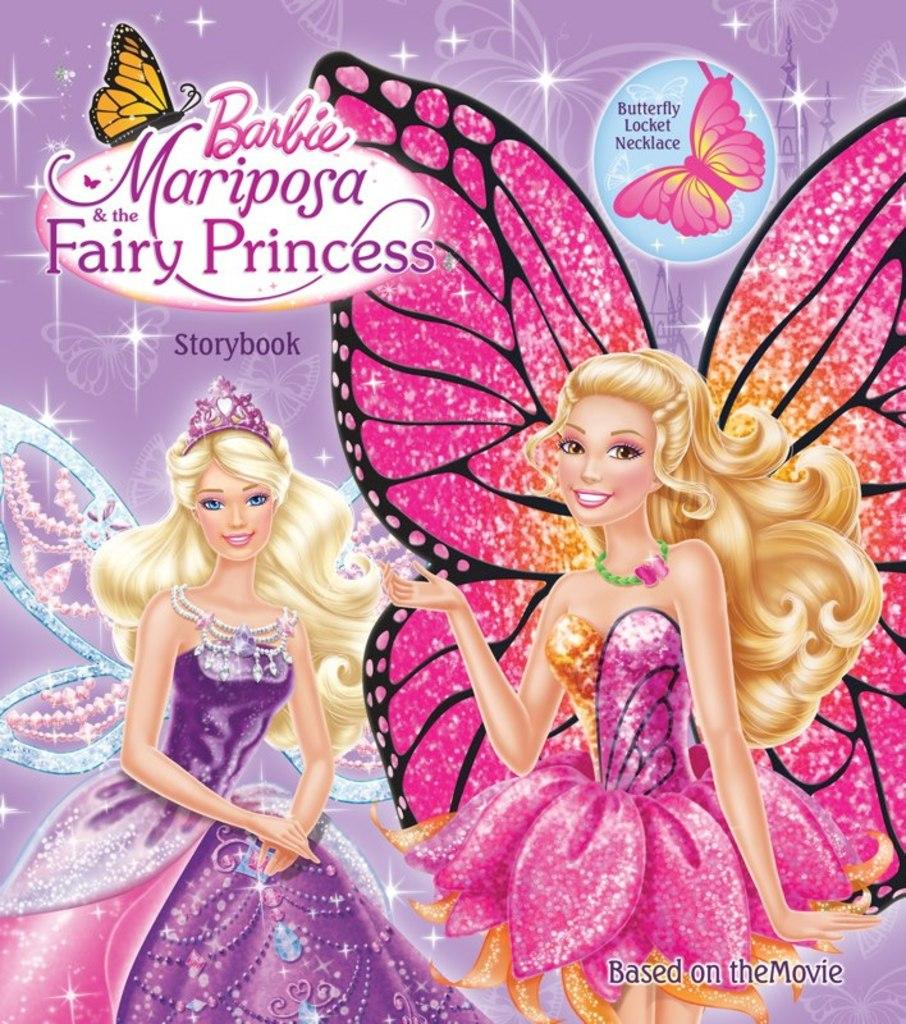What is featured on the poster in the image? There is a poster in the image that contains two baby girl pictures. What are the baby girls doing in the pictures? The baby girls have wings in the pictures. What is the title of the poster? The name "Barbie Mariposa Fairy Princess" is on the poster. What toys can be seen in the morning in the image? There are no toys or reference to morning in the image; it features a poster with baby girl pictures. 